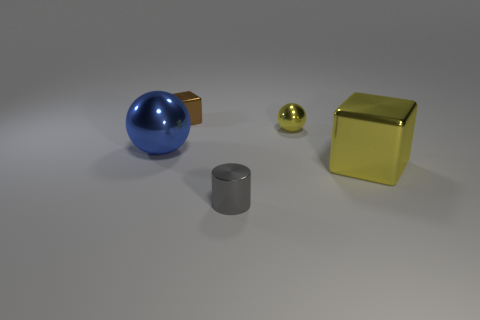Add 2 big yellow cubes. How many objects exist? 7 Subtract 1 cubes. How many cubes are left? 1 Subtract all cubes. How many objects are left? 3 Add 5 tiny spheres. How many tiny spheres exist? 6 Subtract 0 cyan balls. How many objects are left? 5 Subtract all yellow cubes. Subtract all gray cylinders. How many cubes are left? 1 Subtract all gray cylinders. How many yellow balls are left? 1 Subtract all large things. Subtract all brown things. How many objects are left? 2 Add 5 tiny brown metallic objects. How many tiny brown metallic objects are left? 6 